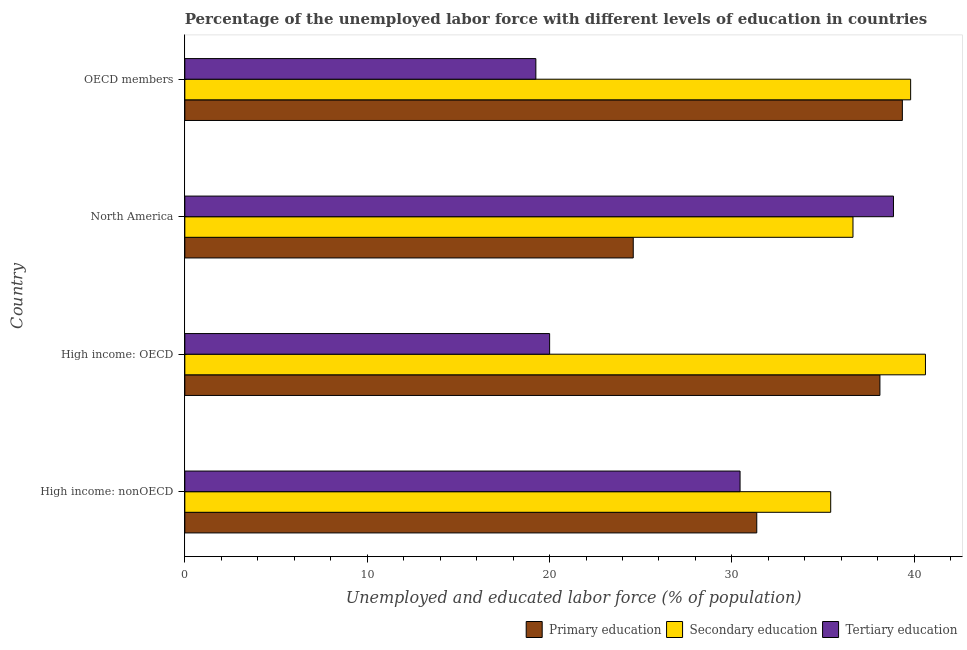Are the number of bars per tick equal to the number of legend labels?
Provide a short and direct response. Yes. How many bars are there on the 2nd tick from the top?
Keep it short and to the point. 3. How many bars are there on the 3rd tick from the bottom?
Your answer should be very brief. 3. What is the label of the 3rd group of bars from the top?
Your answer should be compact. High income: OECD. In how many cases, is the number of bars for a given country not equal to the number of legend labels?
Offer a very short reply. 0. What is the percentage of labor force who received tertiary education in High income: nonOECD?
Give a very brief answer. 30.45. Across all countries, what is the maximum percentage of labor force who received primary education?
Offer a very short reply. 39.35. Across all countries, what is the minimum percentage of labor force who received primary education?
Your response must be concise. 24.59. In which country was the percentage of labor force who received secondary education maximum?
Provide a succinct answer. High income: OECD. In which country was the percentage of labor force who received tertiary education minimum?
Provide a short and direct response. OECD members. What is the total percentage of labor force who received secondary education in the graph?
Your answer should be very brief. 152.47. What is the difference between the percentage of labor force who received tertiary education in High income: OECD and that in High income: nonOECD?
Your response must be concise. -10.44. What is the difference between the percentage of labor force who received tertiary education in High income: OECD and the percentage of labor force who received primary education in North America?
Keep it short and to the point. -4.59. What is the average percentage of labor force who received primary education per country?
Your response must be concise. 33.35. What is the difference between the percentage of labor force who received secondary education and percentage of labor force who received primary education in High income: OECD?
Provide a short and direct response. 2.5. In how many countries, is the percentage of labor force who received secondary education greater than 8 %?
Keep it short and to the point. 4. What is the ratio of the percentage of labor force who received tertiary education in High income: nonOECD to that in North America?
Your response must be concise. 0.78. Is the percentage of labor force who received secondary education in High income: OECD less than that in OECD members?
Make the answer very short. No. What is the difference between the highest and the second highest percentage of labor force who received primary education?
Offer a very short reply. 1.23. What is the difference between the highest and the lowest percentage of labor force who received primary education?
Provide a succinct answer. 14.76. What does the 1st bar from the top in OECD members represents?
Give a very brief answer. Tertiary education. What does the 3rd bar from the bottom in OECD members represents?
Ensure brevity in your answer.  Tertiary education. What is the difference between two consecutive major ticks on the X-axis?
Make the answer very short. 10. Are the values on the major ticks of X-axis written in scientific E-notation?
Provide a short and direct response. No. How many legend labels are there?
Your answer should be very brief. 3. What is the title of the graph?
Your answer should be very brief. Percentage of the unemployed labor force with different levels of education in countries. What is the label or title of the X-axis?
Make the answer very short. Unemployed and educated labor force (% of population). What is the label or title of the Y-axis?
Provide a short and direct response. Country. What is the Unemployed and educated labor force (% of population) in Primary education in High income: nonOECD?
Give a very brief answer. 31.36. What is the Unemployed and educated labor force (% of population) of Secondary education in High income: nonOECD?
Offer a very short reply. 35.42. What is the Unemployed and educated labor force (% of population) of Tertiary education in High income: nonOECD?
Ensure brevity in your answer.  30.45. What is the Unemployed and educated labor force (% of population) of Primary education in High income: OECD?
Offer a very short reply. 38.12. What is the Unemployed and educated labor force (% of population) in Secondary education in High income: OECD?
Ensure brevity in your answer.  40.61. What is the Unemployed and educated labor force (% of population) of Tertiary education in High income: OECD?
Provide a short and direct response. 20. What is the Unemployed and educated labor force (% of population) of Primary education in North America?
Your answer should be very brief. 24.59. What is the Unemployed and educated labor force (% of population) of Secondary education in North America?
Ensure brevity in your answer.  36.64. What is the Unemployed and educated labor force (% of population) in Tertiary education in North America?
Give a very brief answer. 38.86. What is the Unemployed and educated labor force (% of population) in Primary education in OECD members?
Offer a very short reply. 39.35. What is the Unemployed and educated labor force (% of population) in Secondary education in OECD members?
Make the answer very short. 39.8. What is the Unemployed and educated labor force (% of population) in Tertiary education in OECD members?
Your answer should be compact. 19.25. Across all countries, what is the maximum Unemployed and educated labor force (% of population) of Primary education?
Provide a short and direct response. 39.35. Across all countries, what is the maximum Unemployed and educated labor force (% of population) of Secondary education?
Offer a terse response. 40.61. Across all countries, what is the maximum Unemployed and educated labor force (% of population) in Tertiary education?
Offer a very short reply. 38.86. Across all countries, what is the minimum Unemployed and educated labor force (% of population) of Primary education?
Offer a terse response. 24.59. Across all countries, what is the minimum Unemployed and educated labor force (% of population) of Secondary education?
Your answer should be compact. 35.42. Across all countries, what is the minimum Unemployed and educated labor force (% of population) in Tertiary education?
Offer a terse response. 19.25. What is the total Unemployed and educated labor force (% of population) of Primary education in the graph?
Make the answer very short. 133.41. What is the total Unemployed and educated labor force (% of population) in Secondary education in the graph?
Offer a terse response. 152.47. What is the total Unemployed and educated labor force (% of population) of Tertiary education in the graph?
Give a very brief answer. 108.56. What is the difference between the Unemployed and educated labor force (% of population) of Primary education in High income: nonOECD and that in High income: OECD?
Provide a short and direct response. -6.75. What is the difference between the Unemployed and educated labor force (% of population) in Secondary education in High income: nonOECD and that in High income: OECD?
Provide a short and direct response. -5.2. What is the difference between the Unemployed and educated labor force (% of population) in Tertiary education in High income: nonOECD and that in High income: OECD?
Ensure brevity in your answer.  10.44. What is the difference between the Unemployed and educated labor force (% of population) of Primary education in High income: nonOECD and that in North America?
Offer a very short reply. 6.77. What is the difference between the Unemployed and educated labor force (% of population) in Secondary education in High income: nonOECD and that in North America?
Your answer should be compact. -1.22. What is the difference between the Unemployed and educated labor force (% of population) in Tertiary education in High income: nonOECD and that in North America?
Your response must be concise. -8.41. What is the difference between the Unemployed and educated labor force (% of population) of Primary education in High income: nonOECD and that in OECD members?
Offer a terse response. -7.98. What is the difference between the Unemployed and educated labor force (% of population) of Secondary education in High income: nonOECD and that in OECD members?
Your answer should be compact. -4.38. What is the difference between the Unemployed and educated labor force (% of population) of Tertiary education in High income: nonOECD and that in OECD members?
Your response must be concise. 11.2. What is the difference between the Unemployed and educated labor force (% of population) in Primary education in High income: OECD and that in North America?
Provide a short and direct response. 13.53. What is the difference between the Unemployed and educated labor force (% of population) in Secondary education in High income: OECD and that in North America?
Provide a succinct answer. 3.97. What is the difference between the Unemployed and educated labor force (% of population) of Tertiary education in High income: OECD and that in North America?
Your answer should be very brief. -18.85. What is the difference between the Unemployed and educated labor force (% of population) in Primary education in High income: OECD and that in OECD members?
Provide a succinct answer. -1.23. What is the difference between the Unemployed and educated labor force (% of population) of Secondary education in High income: OECD and that in OECD members?
Keep it short and to the point. 0.81. What is the difference between the Unemployed and educated labor force (% of population) of Tertiary education in High income: OECD and that in OECD members?
Your answer should be compact. 0.75. What is the difference between the Unemployed and educated labor force (% of population) of Primary education in North America and that in OECD members?
Keep it short and to the point. -14.76. What is the difference between the Unemployed and educated labor force (% of population) of Secondary education in North America and that in OECD members?
Your answer should be compact. -3.16. What is the difference between the Unemployed and educated labor force (% of population) of Tertiary education in North America and that in OECD members?
Make the answer very short. 19.61. What is the difference between the Unemployed and educated labor force (% of population) in Primary education in High income: nonOECD and the Unemployed and educated labor force (% of population) in Secondary education in High income: OECD?
Your response must be concise. -9.25. What is the difference between the Unemployed and educated labor force (% of population) of Primary education in High income: nonOECD and the Unemployed and educated labor force (% of population) of Tertiary education in High income: OECD?
Keep it short and to the point. 11.36. What is the difference between the Unemployed and educated labor force (% of population) in Secondary education in High income: nonOECD and the Unemployed and educated labor force (% of population) in Tertiary education in High income: OECD?
Provide a short and direct response. 15.41. What is the difference between the Unemployed and educated labor force (% of population) in Primary education in High income: nonOECD and the Unemployed and educated labor force (% of population) in Secondary education in North America?
Offer a very short reply. -5.28. What is the difference between the Unemployed and educated labor force (% of population) of Primary education in High income: nonOECD and the Unemployed and educated labor force (% of population) of Tertiary education in North America?
Provide a short and direct response. -7.5. What is the difference between the Unemployed and educated labor force (% of population) in Secondary education in High income: nonOECD and the Unemployed and educated labor force (% of population) in Tertiary education in North America?
Offer a terse response. -3.44. What is the difference between the Unemployed and educated labor force (% of population) of Primary education in High income: nonOECD and the Unemployed and educated labor force (% of population) of Secondary education in OECD members?
Make the answer very short. -8.44. What is the difference between the Unemployed and educated labor force (% of population) in Primary education in High income: nonOECD and the Unemployed and educated labor force (% of population) in Tertiary education in OECD members?
Your answer should be very brief. 12.11. What is the difference between the Unemployed and educated labor force (% of population) of Secondary education in High income: nonOECD and the Unemployed and educated labor force (% of population) of Tertiary education in OECD members?
Provide a succinct answer. 16.17. What is the difference between the Unemployed and educated labor force (% of population) of Primary education in High income: OECD and the Unemployed and educated labor force (% of population) of Secondary education in North America?
Provide a succinct answer. 1.48. What is the difference between the Unemployed and educated labor force (% of population) of Primary education in High income: OECD and the Unemployed and educated labor force (% of population) of Tertiary education in North America?
Provide a succinct answer. -0.74. What is the difference between the Unemployed and educated labor force (% of population) in Secondary education in High income: OECD and the Unemployed and educated labor force (% of population) in Tertiary education in North America?
Keep it short and to the point. 1.75. What is the difference between the Unemployed and educated labor force (% of population) of Primary education in High income: OECD and the Unemployed and educated labor force (% of population) of Secondary education in OECD members?
Your response must be concise. -1.68. What is the difference between the Unemployed and educated labor force (% of population) in Primary education in High income: OECD and the Unemployed and educated labor force (% of population) in Tertiary education in OECD members?
Provide a short and direct response. 18.87. What is the difference between the Unemployed and educated labor force (% of population) of Secondary education in High income: OECD and the Unemployed and educated labor force (% of population) of Tertiary education in OECD members?
Your response must be concise. 21.36. What is the difference between the Unemployed and educated labor force (% of population) in Primary education in North America and the Unemployed and educated labor force (% of population) in Secondary education in OECD members?
Give a very brief answer. -15.21. What is the difference between the Unemployed and educated labor force (% of population) of Primary education in North America and the Unemployed and educated labor force (% of population) of Tertiary education in OECD members?
Your response must be concise. 5.34. What is the difference between the Unemployed and educated labor force (% of population) in Secondary education in North America and the Unemployed and educated labor force (% of population) in Tertiary education in OECD members?
Your response must be concise. 17.39. What is the average Unemployed and educated labor force (% of population) in Primary education per country?
Your answer should be very brief. 33.35. What is the average Unemployed and educated labor force (% of population) in Secondary education per country?
Offer a terse response. 38.12. What is the average Unemployed and educated labor force (% of population) in Tertiary education per country?
Provide a short and direct response. 27.14. What is the difference between the Unemployed and educated labor force (% of population) in Primary education and Unemployed and educated labor force (% of population) in Secondary education in High income: nonOECD?
Ensure brevity in your answer.  -4.05. What is the difference between the Unemployed and educated labor force (% of population) in Primary education and Unemployed and educated labor force (% of population) in Tertiary education in High income: nonOECD?
Ensure brevity in your answer.  0.92. What is the difference between the Unemployed and educated labor force (% of population) in Secondary education and Unemployed and educated labor force (% of population) in Tertiary education in High income: nonOECD?
Ensure brevity in your answer.  4.97. What is the difference between the Unemployed and educated labor force (% of population) in Primary education and Unemployed and educated labor force (% of population) in Secondary education in High income: OECD?
Offer a very short reply. -2.5. What is the difference between the Unemployed and educated labor force (% of population) in Primary education and Unemployed and educated labor force (% of population) in Tertiary education in High income: OECD?
Make the answer very short. 18.11. What is the difference between the Unemployed and educated labor force (% of population) in Secondary education and Unemployed and educated labor force (% of population) in Tertiary education in High income: OECD?
Give a very brief answer. 20.61. What is the difference between the Unemployed and educated labor force (% of population) in Primary education and Unemployed and educated labor force (% of population) in Secondary education in North America?
Your answer should be very brief. -12.05. What is the difference between the Unemployed and educated labor force (% of population) of Primary education and Unemployed and educated labor force (% of population) of Tertiary education in North America?
Offer a terse response. -14.27. What is the difference between the Unemployed and educated labor force (% of population) in Secondary education and Unemployed and educated labor force (% of population) in Tertiary education in North America?
Your answer should be very brief. -2.22. What is the difference between the Unemployed and educated labor force (% of population) of Primary education and Unemployed and educated labor force (% of population) of Secondary education in OECD members?
Your response must be concise. -0.45. What is the difference between the Unemployed and educated labor force (% of population) of Primary education and Unemployed and educated labor force (% of population) of Tertiary education in OECD members?
Your response must be concise. 20.1. What is the difference between the Unemployed and educated labor force (% of population) in Secondary education and Unemployed and educated labor force (% of population) in Tertiary education in OECD members?
Make the answer very short. 20.55. What is the ratio of the Unemployed and educated labor force (% of population) of Primary education in High income: nonOECD to that in High income: OECD?
Offer a terse response. 0.82. What is the ratio of the Unemployed and educated labor force (% of population) in Secondary education in High income: nonOECD to that in High income: OECD?
Give a very brief answer. 0.87. What is the ratio of the Unemployed and educated labor force (% of population) of Tertiary education in High income: nonOECD to that in High income: OECD?
Give a very brief answer. 1.52. What is the ratio of the Unemployed and educated labor force (% of population) of Primary education in High income: nonOECD to that in North America?
Provide a succinct answer. 1.28. What is the ratio of the Unemployed and educated labor force (% of population) of Secondary education in High income: nonOECD to that in North America?
Provide a short and direct response. 0.97. What is the ratio of the Unemployed and educated labor force (% of population) of Tertiary education in High income: nonOECD to that in North America?
Make the answer very short. 0.78. What is the ratio of the Unemployed and educated labor force (% of population) in Primary education in High income: nonOECD to that in OECD members?
Offer a terse response. 0.8. What is the ratio of the Unemployed and educated labor force (% of population) of Secondary education in High income: nonOECD to that in OECD members?
Offer a very short reply. 0.89. What is the ratio of the Unemployed and educated labor force (% of population) of Tertiary education in High income: nonOECD to that in OECD members?
Provide a succinct answer. 1.58. What is the ratio of the Unemployed and educated labor force (% of population) of Primary education in High income: OECD to that in North America?
Keep it short and to the point. 1.55. What is the ratio of the Unemployed and educated labor force (% of population) in Secondary education in High income: OECD to that in North America?
Ensure brevity in your answer.  1.11. What is the ratio of the Unemployed and educated labor force (% of population) in Tertiary education in High income: OECD to that in North America?
Give a very brief answer. 0.51. What is the ratio of the Unemployed and educated labor force (% of population) of Primary education in High income: OECD to that in OECD members?
Ensure brevity in your answer.  0.97. What is the ratio of the Unemployed and educated labor force (% of population) in Secondary education in High income: OECD to that in OECD members?
Offer a very short reply. 1.02. What is the ratio of the Unemployed and educated labor force (% of population) of Tertiary education in High income: OECD to that in OECD members?
Provide a short and direct response. 1.04. What is the ratio of the Unemployed and educated labor force (% of population) in Primary education in North America to that in OECD members?
Offer a very short reply. 0.62. What is the ratio of the Unemployed and educated labor force (% of population) of Secondary education in North America to that in OECD members?
Your answer should be very brief. 0.92. What is the ratio of the Unemployed and educated labor force (% of population) of Tertiary education in North America to that in OECD members?
Your answer should be compact. 2.02. What is the difference between the highest and the second highest Unemployed and educated labor force (% of population) of Primary education?
Ensure brevity in your answer.  1.23. What is the difference between the highest and the second highest Unemployed and educated labor force (% of population) of Secondary education?
Keep it short and to the point. 0.81. What is the difference between the highest and the second highest Unemployed and educated labor force (% of population) in Tertiary education?
Your answer should be very brief. 8.41. What is the difference between the highest and the lowest Unemployed and educated labor force (% of population) in Primary education?
Give a very brief answer. 14.76. What is the difference between the highest and the lowest Unemployed and educated labor force (% of population) of Secondary education?
Provide a succinct answer. 5.2. What is the difference between the highest and the lowest Unemployed and educated labor force (% of population) of Tertiary education?
Provide a succinct answer. 19.61. 